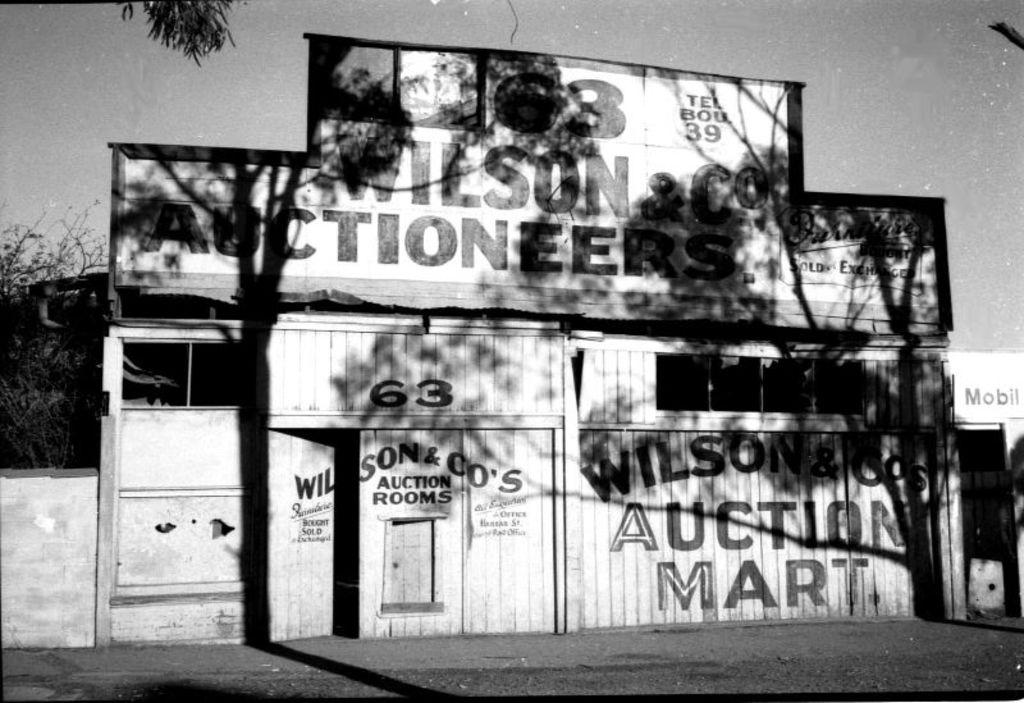What type of surface can be seen in the image? There is ground visible in the image. What is located beside the ground? There is a wooden wall beside the ground. What type of decorations are present in the image? Posters are present in the image. What else can be seen in the image besides the ground, wooden wall, and posters? There are objects visible in the image. What can be seen in the background of the image? There are trees and the sky visible in the background of the image. How many shelves are visible in the image? There is no mention of shelves in the provided facts, so we cannot determine the number of shelves in the image. What do the trees in the background believe about the sky? Trees do not have beliefs, so this question cannot be answered. 